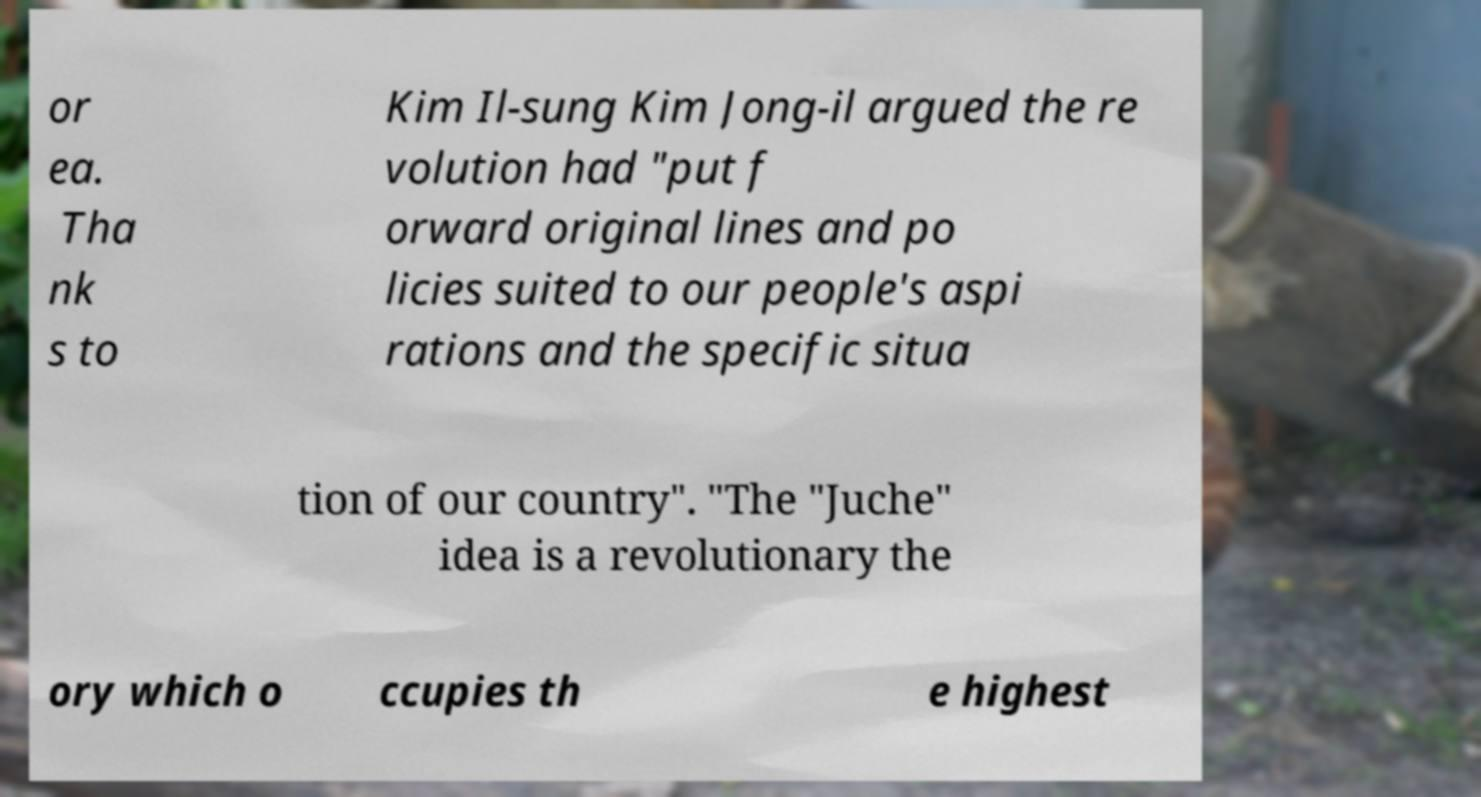Can you accurately transcribe the text from the provided image for me? or ea. Tha nk s to Kim Il-sung Kim Jong-il argued the re volution had "put f orward original lines and po licies suited to our people's aspi rations and the specific situa tion of our country". "The "Juche" idea is a revolutionary the ory which o ccupies th e highest 